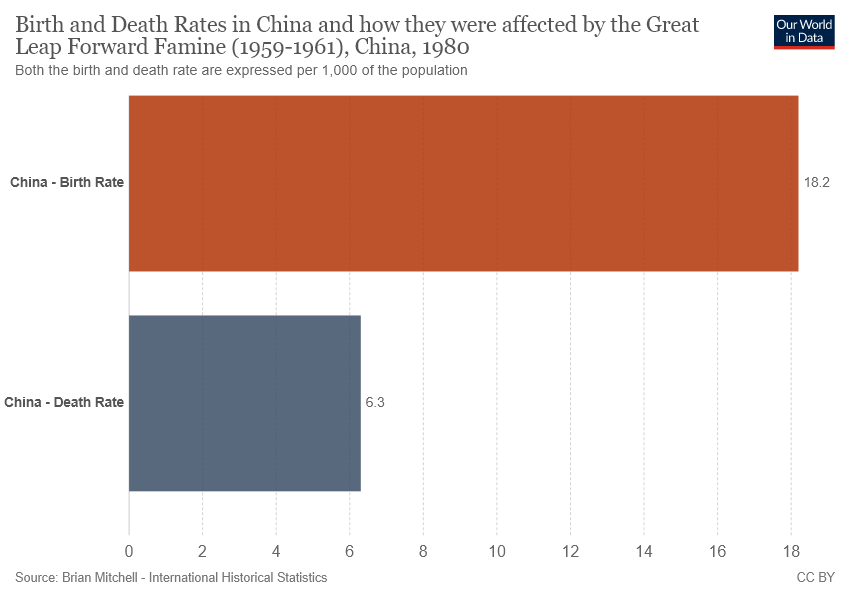Specify some key components in this picture. The difference in birth rate and death rate between China and another country is greater than 10. The death rate in China is 6.3.. 